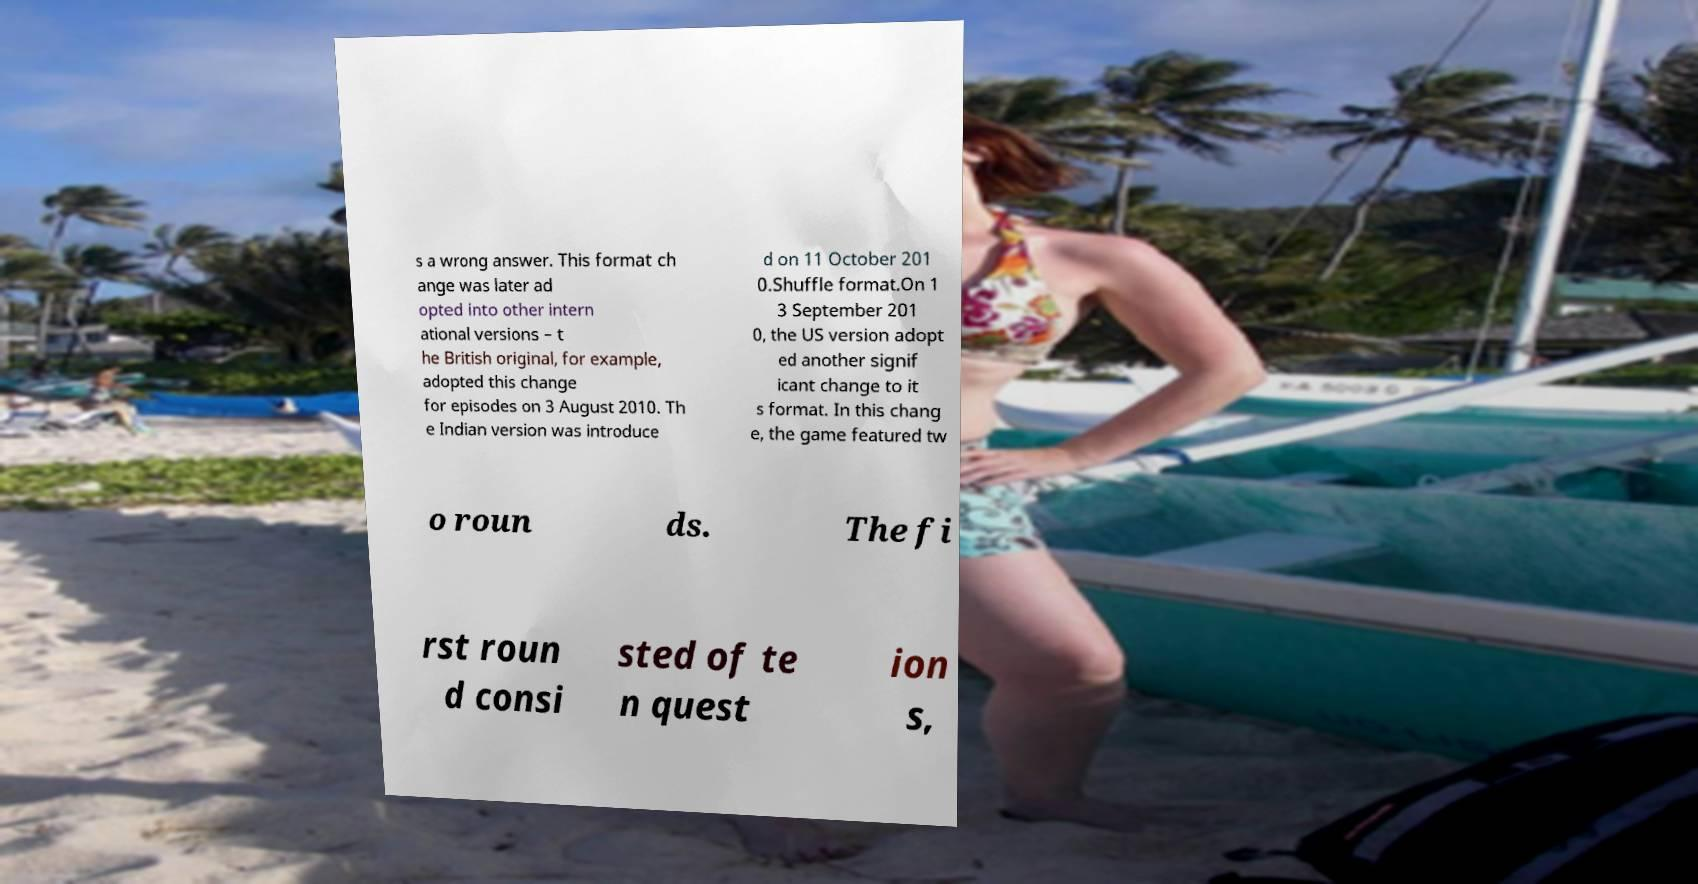What messages or text are displayed in this image? I need them in a readable, typed format. s a wrong answer. This format ch ange was later ad opted into other intern ational versions – t he British original, for example, adopted this change for episodes on 3 August 2010. Th e Indian version was introduce d on 11 October 201 0.Shuffle format.On 1 3 September 201 0, the US version adopt ed another signif icant change to it s format. In this chang e, the game featured tw o roun ds. The fi rst roun d consi sted of te n quest ion s, 